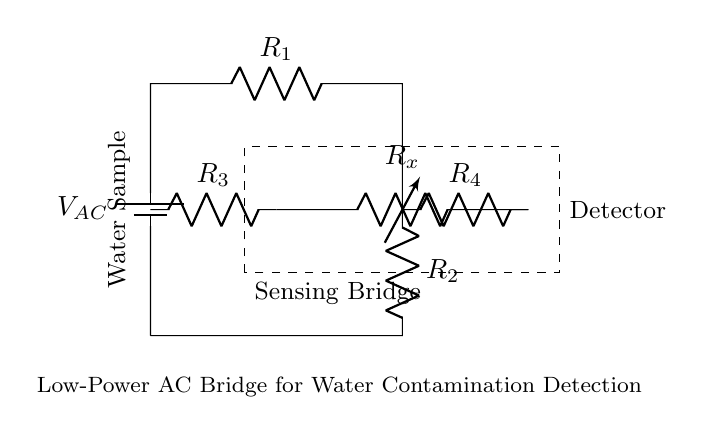What is the type of voltage source used in this circuit? The circuit uses an AC voltage source, indicated by the notation 'V_{AC}' next to the battery symbol, which represents alternating current.
Answer: AC How many resistors are present in the circuit? There are four resistors shown in the circuit diagram, labeled as R1, R2, R3, and R4, corresponding to different sections of the bridge.
Answer: 4 What does the dashed rectangle signify in this circuit? The dashed rectangle outlines the sensing bridge, indicating that the components inside (R3, R4, and R_x) are part of a specific measurement section focused on assessing water contamination.
Answer: Sensing Bridge Which component is used to measure the water sample? The water sample is represented by the notation next to the dashed rectangle, specifically identifying it visually as the area where the sample interacts with the circuit.
Answer: Water Sample What component type is used to analyze the water contamination? The component used for detection in the circuit is labeled as 'R_x', which indicates a variable resistor that adjusts based on water conductivity changes due to contamination.
Answer: R_x What role do resistors R1 and R2 serve in the circuit? Resistors R1 and R2 are part of the bridge network, balancing the circuit to create a condition where the voltage across R_x can indicate the level of contamination in the water sample being tested.
Answer: Balancing 